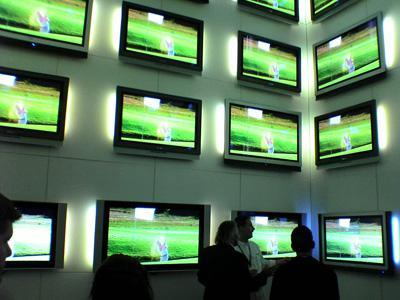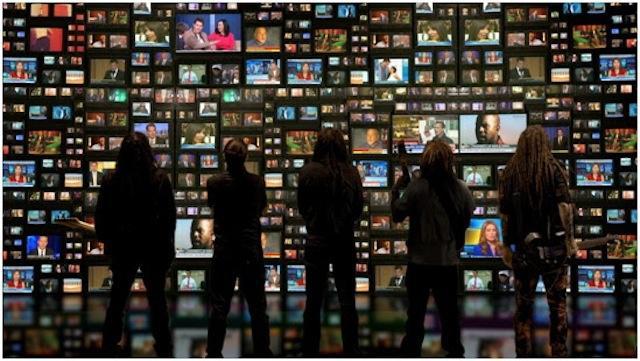The first image is the image on the left, the second image is the image on the right. Evaluate the accuracy of this statement regarding the images: "there is a pile of old tv's outside in front of a brick building". Is it true? Answer yes or no. No. The first image is the image on the left, the second image is the image on the right. Evaluate the accuracy of this statement regarding the images: "The televisions in each of the images are stacked up in piles.". Is it true? Answer yes or no. No. 